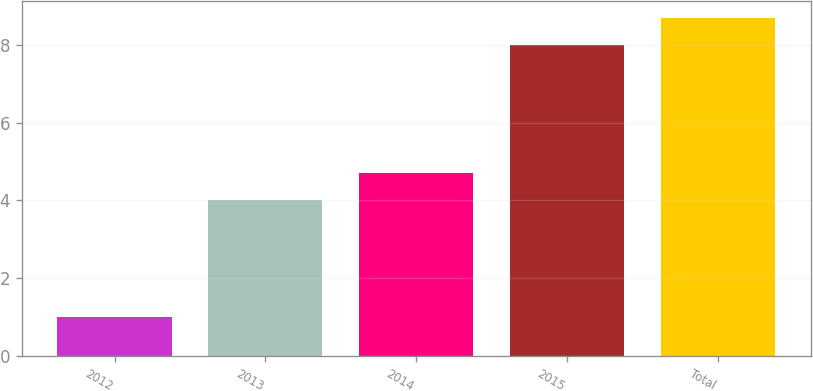<chart> <loc_0><loc_0><loc_500><loc_500><bar_chart><fcel>2012<fcel>2013<fcel>2014<fcel>2015<fcel>Total<nl><fcel>1<fcel>4<fcel>4.7<fcel>8<fcel>8.7<nl></chart> 